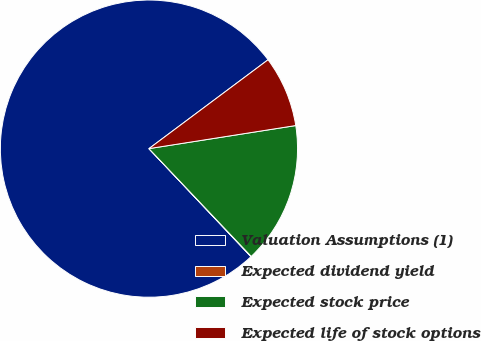Convert chart to OTSL. <chart><loc_0><loc_0><loc_500><loc_500><pie_chart><fcel>Valuation Assumptions (1)<fcel>Expected dividend yield<fcel>Expected stock price<fcel>Expected life of stock options<nl><fcel>76.84%<fcel>0.04%<fcel>15.4%<fcel>7.72%<nl></chart> 